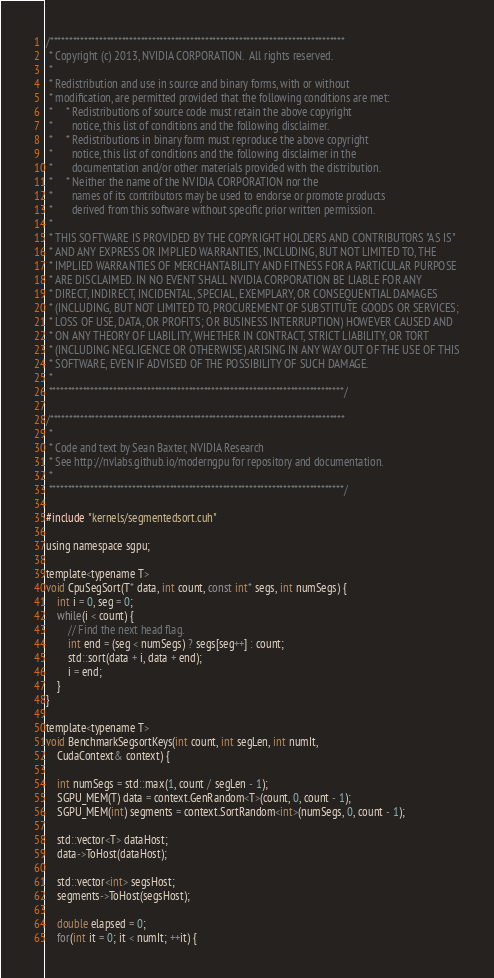<code> <loc_0><loc_0><loc_500><loc_500><_Cuda_>/******************************************************************************
 * Copyright (c) 2013, NVIDIA CORPORATION.  All rights reserved.
 *
 * Redistribution and use in source and binary forms, with or without
 * modification, are permitted provided that the following conditions are met:
 *     * Redistributions of source code must retain the above copyright
 *       notice, this list of conditions and the following disclaimer.
 *     * Redistributions in binary form must reproduce the above copyright
 *       notice, this list of conditions and the following disclaimer in the
 *       documentation and/or other materials provided with the distribution.
 *     * Neither the name of the NVIDIA CORPORATION nor the
 *       names of its contributors may be used to endorse or promote products
 *       derived from this software without specific prior written permission.
 *
 * THIS SOFTWARE IS PROVIDED BY THE COPYRIGHT HOLDERS AND CONTRIBUTORS "AS IS"
 * AND ANY EXPRESS OR IMPLIED WARRANTIES, INCLUDING, BUT NOT LIMITED TO, THE
 * IMPLIED WARRANTIES OF MERCHANTABILITY AND FITNESS FOR A PARTICULAR PURPOSE
 * ARE DISCLAIMED. IN NO EVENT SHALL NVIDIA CORPORATION BE LIABLE FOR ANY
 * DIRECT, INDIRECT, INCIDENTAL, SPECIAL, EXEMPLARY, OR CONSEQUENTIAL DAMAGES
 * (INCLUDING, BUT NOT LIMITED TO, PROCUREMENT OF SUBSTITUTE GOODS OR SERVICES;
 * LOSS OF USE, DATA, OR PROFITS; OR BUSINESS INTERRUPTION) HOWEVER CAUSED AND
 * ON ANY THEORY OF LIABILITY, WHETHER IN CONTRACT, STRICT LIABILITY, OR TORT
 * (INCLUDING NEGLIGENCE OR OTHERWISE) ARISING IN ANY WAY OUT OF THE USE OF THIS
 * SOFTWARE, EVEN IF ADVISED OF THE POSSIBILITY OF SUCH DAMAGE.
 *
 ******************************************************************************/

/******************************************************************************
 *
 * Code and text by Sean Baxter, NVIDIA Research
 * See http://nvlabs.github.io/moderngpu for repository and documentation.
 *
 ******************************************************************************/

#include "kernels/segmentedsort.cuh"

using namespace sgpu;

template<typename T>
void CpuSegSort(T* data, int count, const int* segs, int numSegs) {
	int i = 0, seg = 0;
	while(i < count) {
		// Find the next head flag.
		int end = (seg < numSegs) ? segs[seg++] : count;
		std::sort(data + i, data + end);
		i = end;
	}
}

template<typename T>
void BenchmarkSegsortKeys(int count, int segLen, int numIt,
	CudaContext& context) {

	int numSegs = std::max(1, count / segLen - 1);
	SGPU_MEM(T) data = context.GenRandom<T>(count, 0, count - 1);
	SGPU_MEM(int) segments = context.SortRandom<int>(numSegs, 0, count - 1);

	std::vector<T> dataHost;
	data->ToHost(dataHost);

	std::vector<int> segsHost;
	segments->ToHost(segsHost);

	double elapsed = 0;
	for(int it = 0; it < numIt; ++it) {</code> 